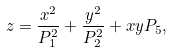Convert formula to latex. <formula><loc_0><loc_0><loc_500><loc_500>z = \frac { x ^ { 2 } } { P _ { 1 } ^ { 2 } } + \frac { y ^ { 2 } } { P _ { 2 } ^ { 2 } } + x y P _ { 5 } ,</formula> 